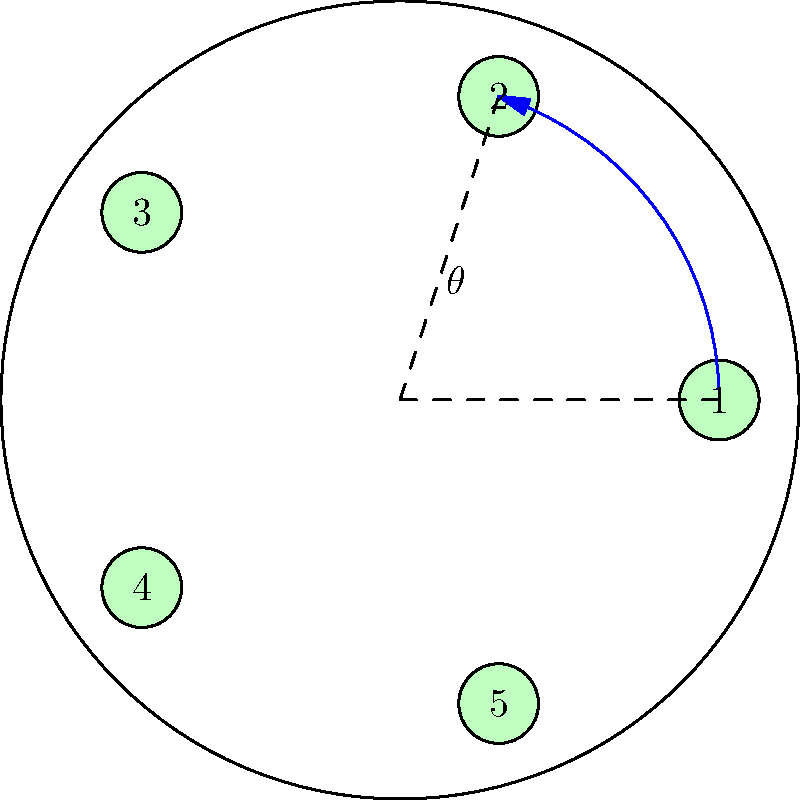You're plating a signature dish with five key ingredients. To maximize visual appeal, you decide to arrange them equidistantly around a circular plate. If the angle between each ingredient is $\theta$, what is the value of $\theta$ in degrees? Let's approach this step-by-step:

1) In a circle, there are 360°.

2) We need to divide the circle into 5 equal parts, one for each ingredient.

3) To calculate the angle between each ingredient, we divide the total degrees in a circle by the number of ingredients:

   $$\theta = \frac{360°}{5}$$

4) Performing the division:

   $$\theta = 72°$$

5) We can verify this by multiplying our result by 5:

   $$72° \times 5 = 360°$$

   This confirms that five angles of 72° will complete a full circle.

6) In the diagram, we can see that the ingredients (numbered 1 to 5) are indeed placed at equal intervals around the circular plate, with the angle $\theta$ shown between two adjacent ingredients.
Answer: 72° 